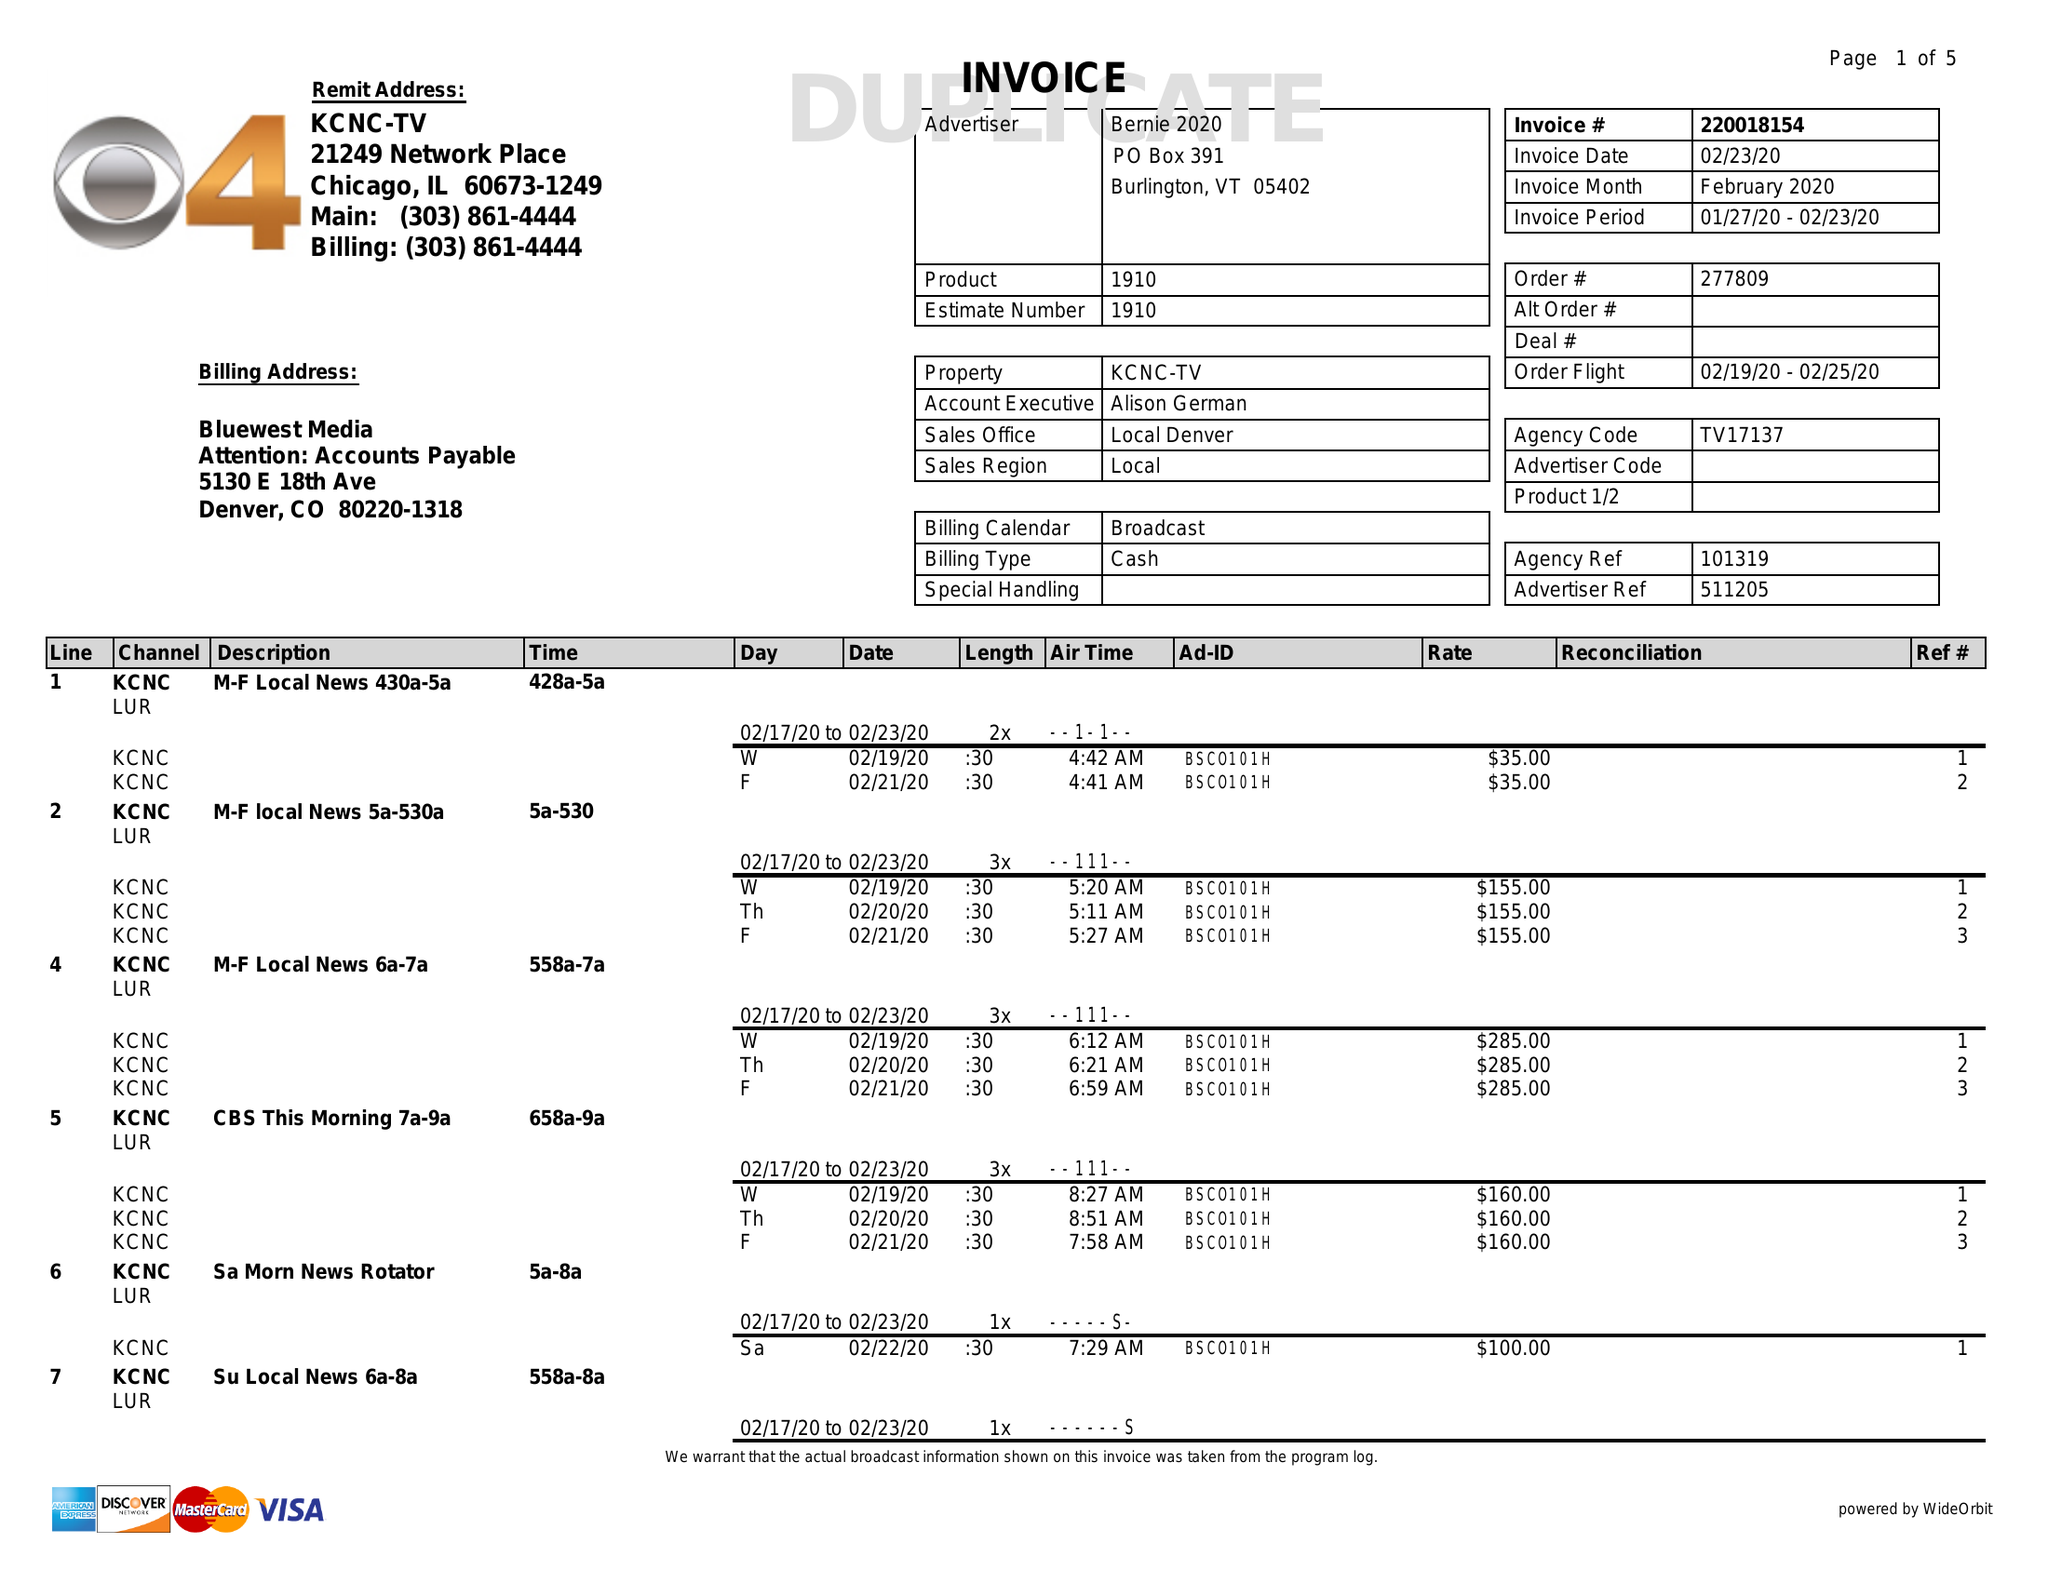What is the value for the flight_to?
Answer the question using a single word or phrase. 02/25/20 